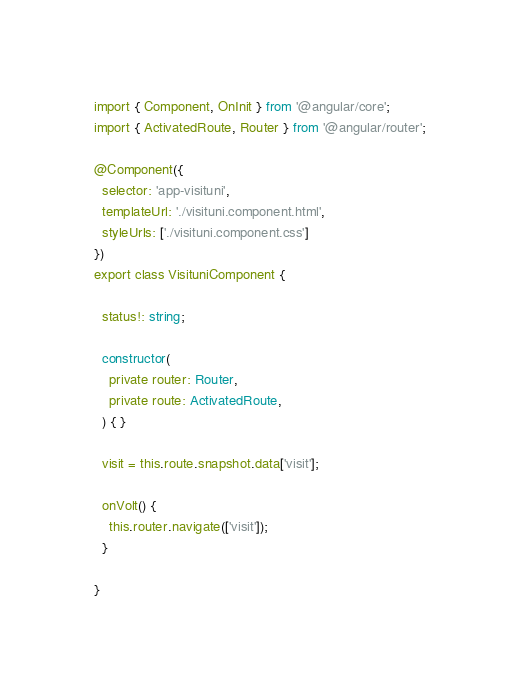Convert code to text. <code><loc_0><loc_0><loc_500><loc_500><_TypeScript_>import { Component, OnInit } from '@angular/core';
import { ActivatedRoute, Router } from '@angular/router';

@Component({
  selector: 'app-visituni',
  templateUrl: './visituni.component.html',
  styleUrls: ['./visituni.component.css']
})
export class VisituniComponent {

  status!: string;

  constructor(
    private router: Router,
    private route: ActivatedRoute,
  ) { }

  visit = this.route.snapshot.data['visit'];

  onVolt() {
    this.router.navigate(['visit']);
  }

}
</code> 